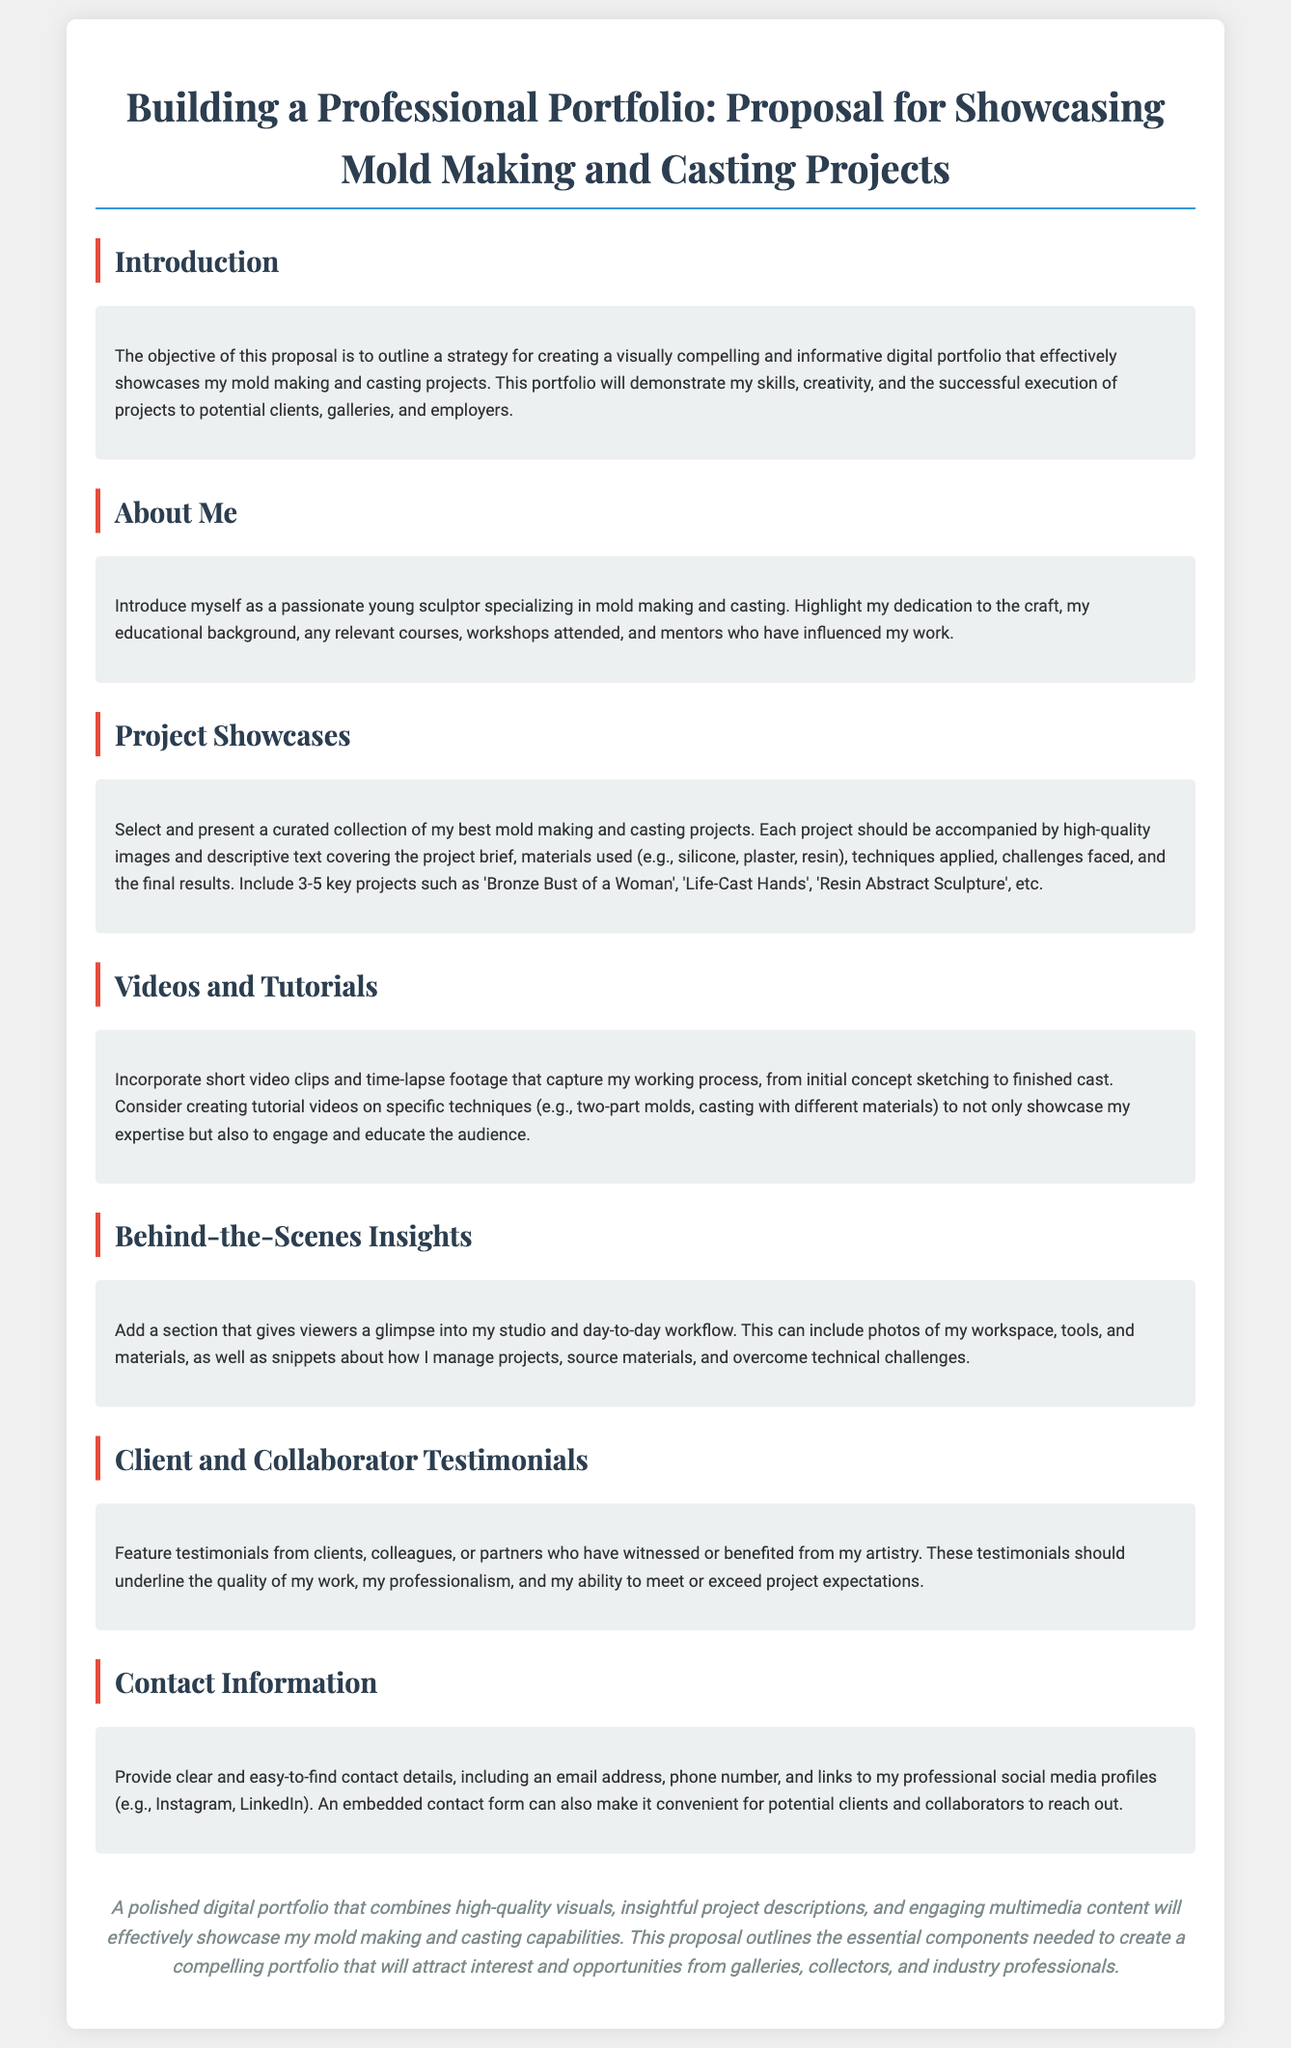What is the proposal about? The proposal outlines a strategy for creating a digital portfolio showcasing mold making and casting projects.
Answer: Digital portfolio showcasing mold making and casting projects Who is the target audience for the portfolio? The portfolio aims to attract potential clients, galleries, and employers.
Answer: Clients, galleries, and employers How many key projects are suggested to showcase? The document recommends including 3-5 key projects in the portfolio.
Answer: 3-5 key projects What type of testimonials should be featured? The proposal suggests including testimonials from clients, colleagues, or partners who can speak about the artistry.
Answer: Clients, colleagues, or partners What multimedia content is proposed to enhance the portfolio? The proposal mentions incorporating short video clips and time-lapse footage of the working process.
Answer: Short video clips and time-lapse footage Why is behind-the-scenes content important? This content provides viewers with insights into the artist's studio and workflow, fostering a deeper connection.
Answer: Insights into workflow and studio What is the main goal of the portfolio? The main goal is to effectively showcase mold making and casting capabilities to attract interest and opportunities.
Answer: Showcase mold making and casting capabilities What contact details should be provided? The proposal indicates the need for an email address, phone number, and links to social media profiles.
Answer: Email, phone number, social media links 